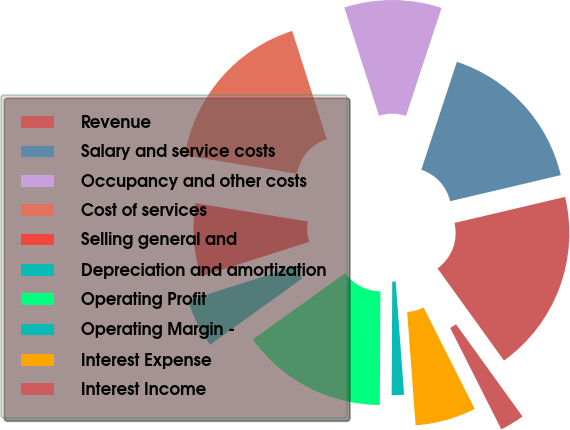<chart> <loc_0><loc_0><loc_500><loc_500><pie_chart><fcel>Revenue<fcel>Salary and service costs<fcel>Occupancy and other costs<fcel>Cost of services<fcel>Selling general and<fcel>Depreciation and amortization<fcel>Operating Profit<fcel>Operating Margin -<fcel>Interest Expense<fcel>Interest Income<nl><fcel>18.74%<fcel>16.25%<fcel>10.0%<fcel>17.49%<fcel>7.5%<fcel>5.0%<fcel>15.0%<fcel>1.26%<fcel>6.25%<fcel>2.51%<nl></chart> 